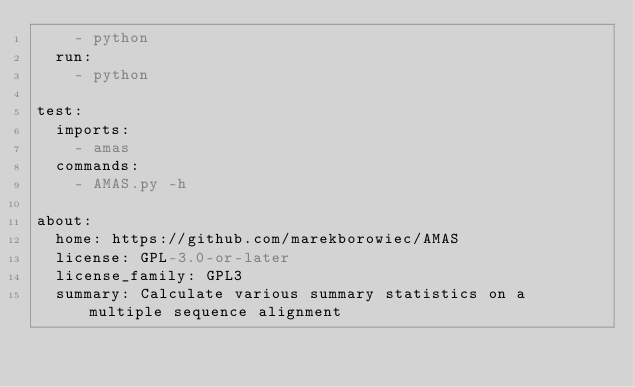Convert code to text. <code><loc_0><loc_0><loc_500><loc_500><_YAML_>    - python
  run:
    - python

test:
  imports:
    - amas
  commands:
    - AMAS.py -h

about:
  home: https://github.com/marekborowiec/AMAS
  license: GPL-3.0-or-later
  license_family: GPL3
  summary: Calculate various summary statistics on a multiple sequence alignment
</code> 